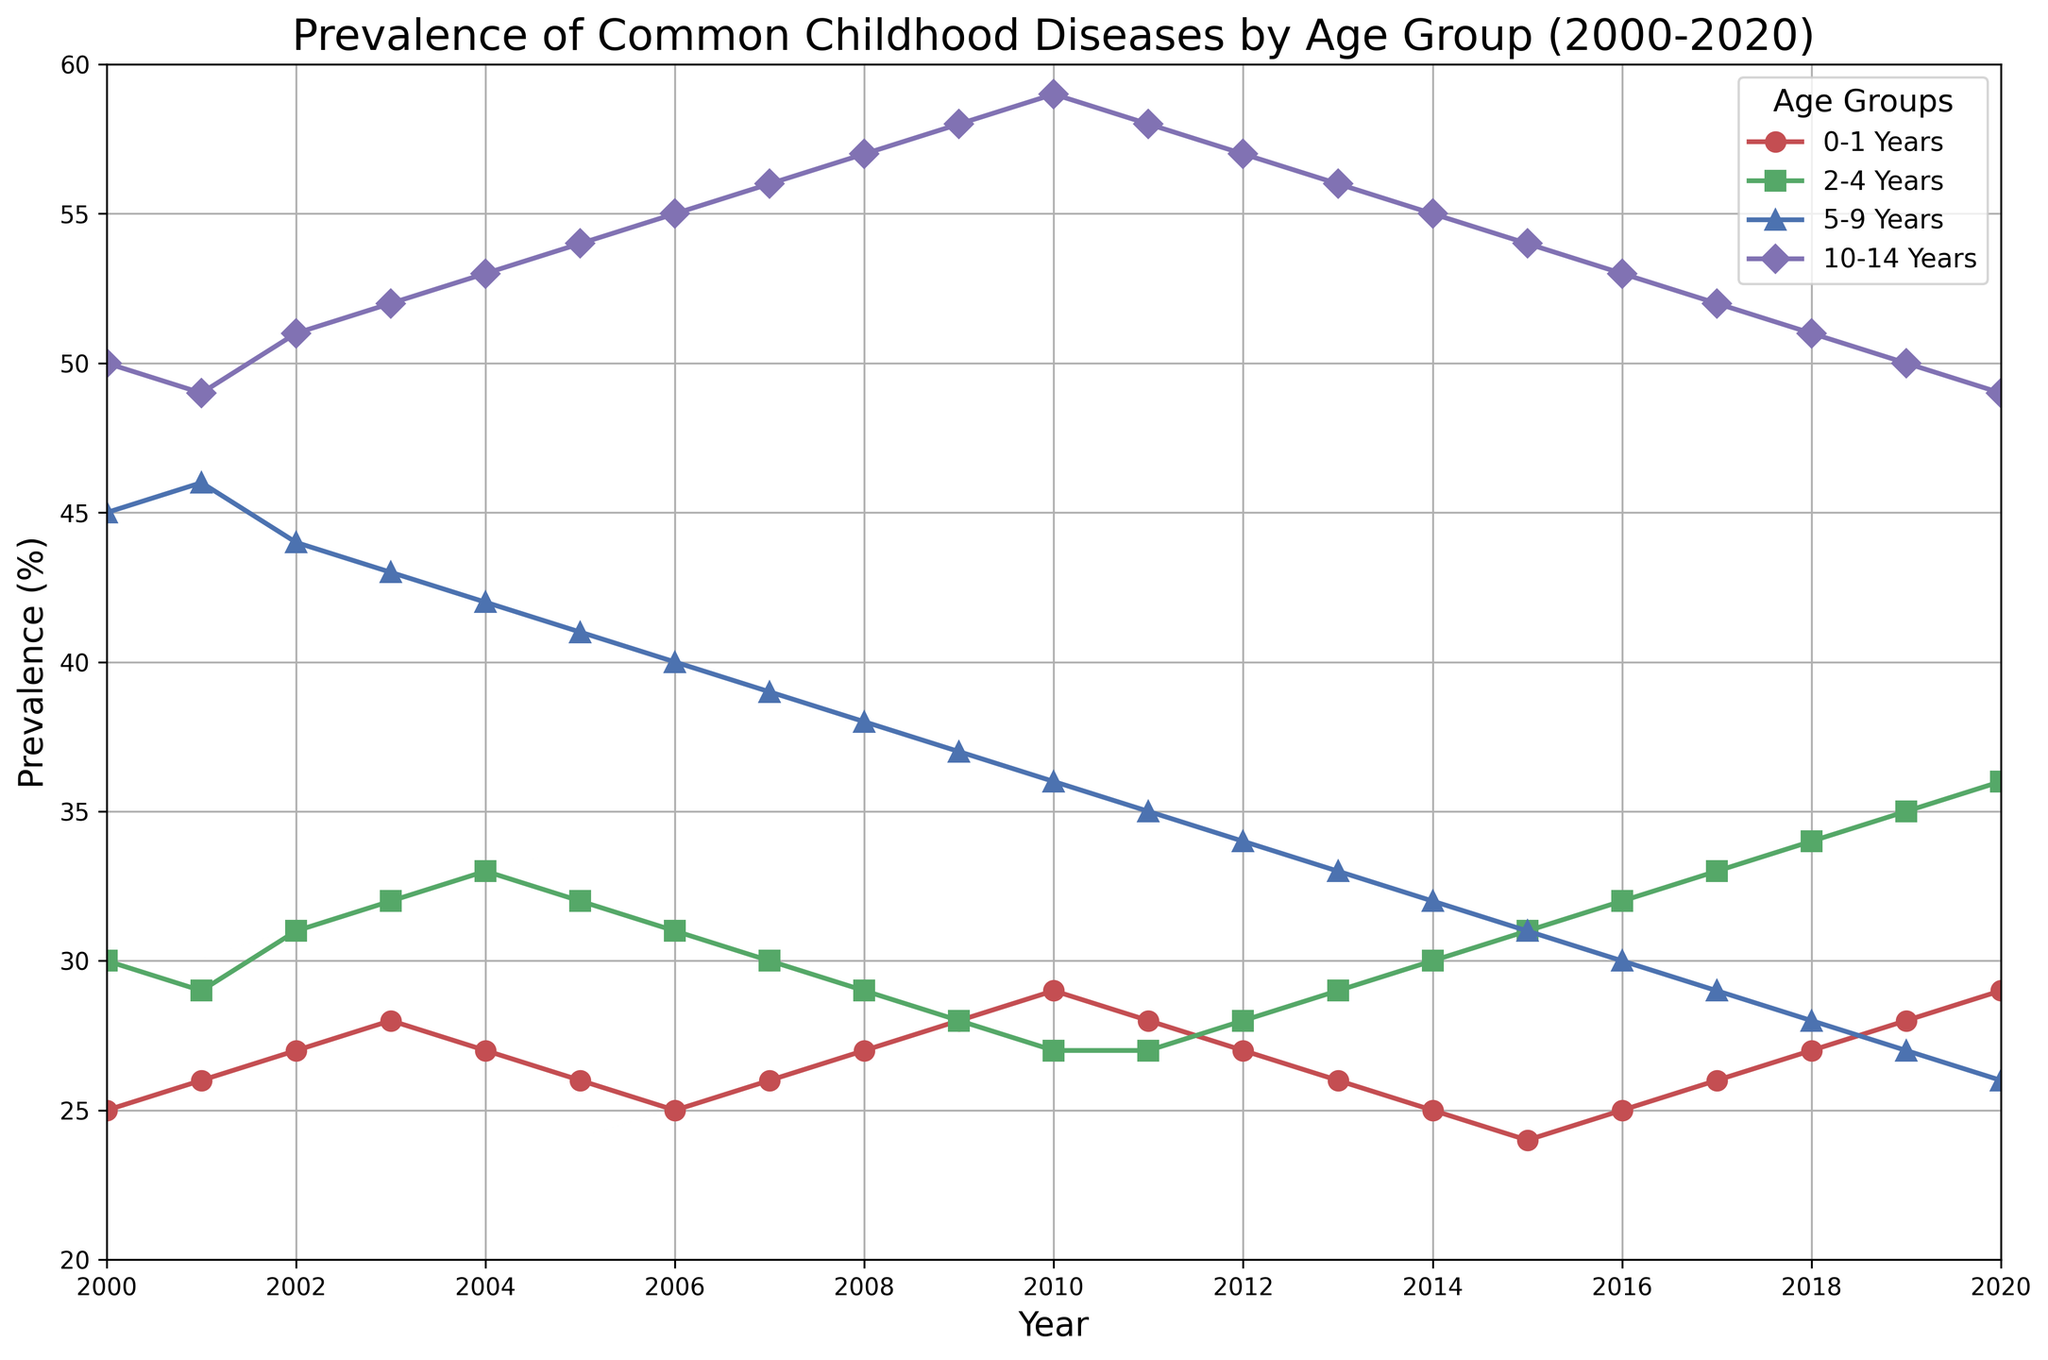What is the prevalence trend for the 5-9 years age group from 2000 to 2020? The plot for the 5-9 years age group shows a declining trend over the years. The prevalence starts around 45% in 2000 and decreases gradually to about 26% by 2020.
Answer: Declining trend Which age group had the highest prevalence in the year 2010? By examining the plot for the year 2010, the 10-14 years age group has the highest prevalence, around 59%, compared to other age groups.
Answer: 10-14 years In which year did the 0-1 years age group see the lowest prevalence? Checking the plot lines for the 0-1 years age group, the lowest prevalence occurs around the year 2015, with a prevalence of approximately 24%.
Answer: 2015 How does the prevalence of diseases in the 2-4 years age group compare between 2005 and 2020? In the year 2005, the prevalence in the 2-4 years age group is around 32%, while in 2020, it increases to 36%. This shows an increase over the years.
Answer: Increase from 32% to 36% What is the difference in prevalence between the highest and lowest age groups in 2020? In 2020, the highest age group is 10-14 years with a prevalence of 49%, and the lowest is 5-9 years with 26%. The difference is 49% - 26% = 23%.
Answer: 23% What’s the average prevalence for the 10-14 years age group between 2000 and 2020? To find the average prevalence for this age group, we sum the values from all the years (50+49+51+52+53+54+55+56+57+58+59+58+57+56+55+54+53+52+51+50+49) and divide by the number of years, which is 21. Total sum = 1120, so the average is 1120/21 ≈ 53.33.
Answer: ≈ 53.33 Which year saw the most significant single-year increase in prevalence for the 0-1 years age group? By comparing the prevalence values year-over-year: the largest single-year increase is from 2009 (28%) to 2010 (29%), an increase of 1%.
Answer: 2010 What is the trend in the prevalence of diseases for the 2-4 years age group from 2015 to 2020? From the plot, the 2-4 years age group shows an increasing trend in prevalence from 2015 (31%) to 2020 (36%).
Answer: Increasing trend Compare the prevalence values for the 5-9 years and 10-14 years age groups in the year 2013. In 2013, according to the plot, the prevalence for the 5-9 years age group is 33%, and for the 10-14 years age group, it is 56%.
Answer: 5-9 years: 33%, 10-14 years: 56% 